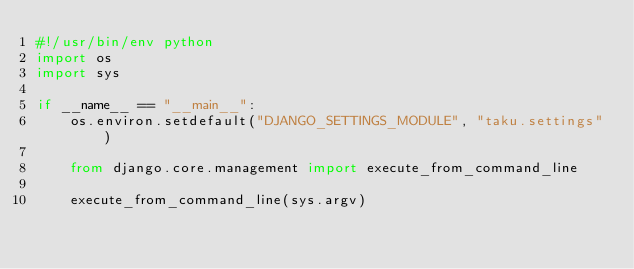Convert code to text. <code><loc_0><loc_0><loc_500><loc_500><_Python_>#!/usr/bin/env python
import os
import sys

if __name__ == "__main__":
    os.environ.setdefault("DJANGO_SETTINGS_MODULE", "taku.settings")

    from django.core.management import execute_from_command_line

    execute_from_command_line(sys.argv)
</code> 